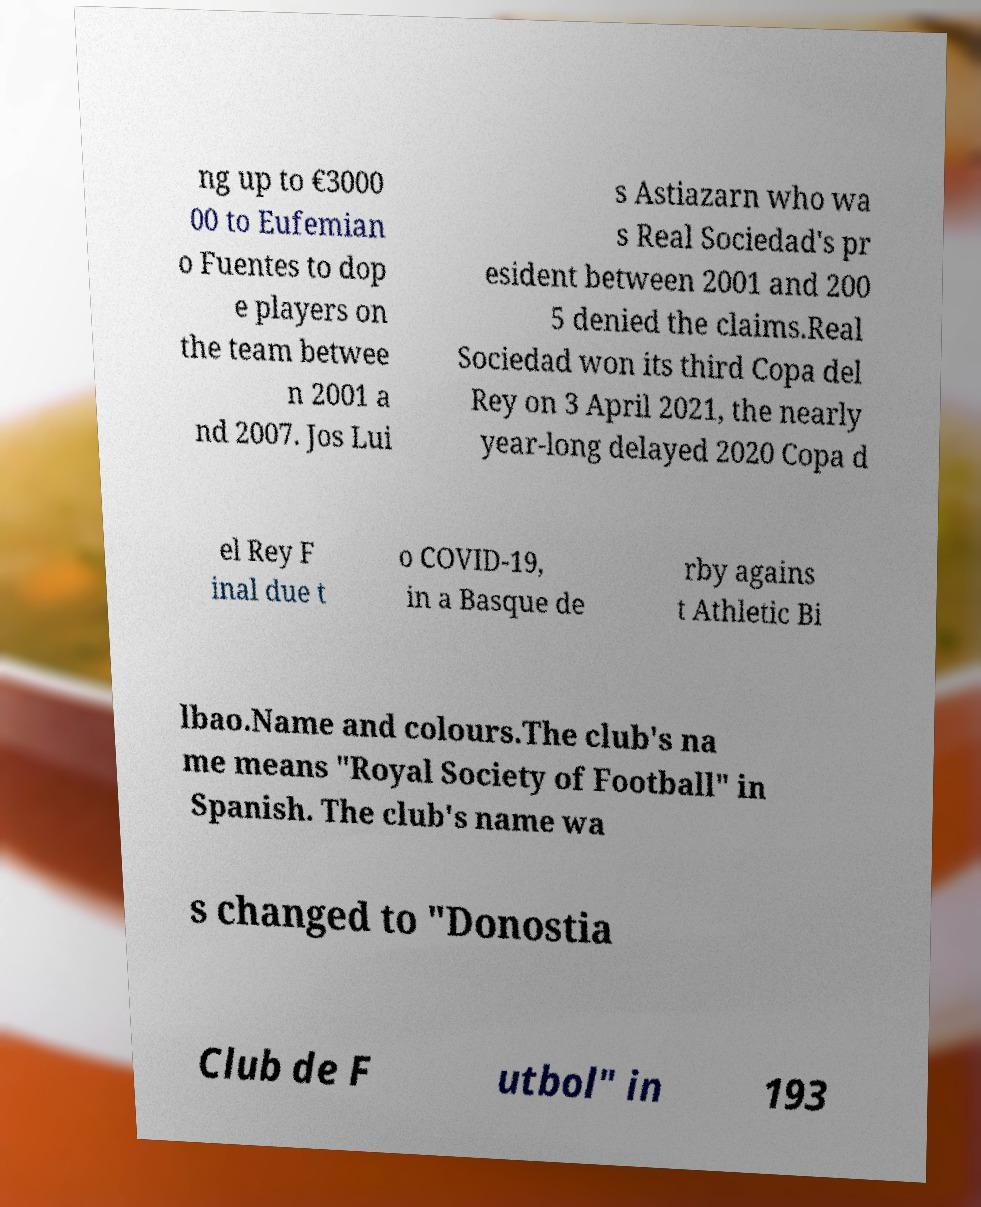There's text embedded in this image that I need extracted. Can you transcribe it verbatim? ng up to €3000 00 to Eufemian o Fuentes to dop e players on the team betwee n 2001 a nd 2007. Jos Lui s Astiazarn who wa s Real Sociedad's pr esident between 2001 and 200 5 denied the claims.Real Sociedad won its third Copa del Rey on 3 April 2021, the nearly year-long delayed 2020 Copa d el Rey F inal due t o COVID-19, in a Basque de rby agains t Athletic Bi lbao.Name and colours.The club's na me means "Royal Society of Football" in Spanish. The club's name wa s changed to "Donostia Club de F utbol" in 193 